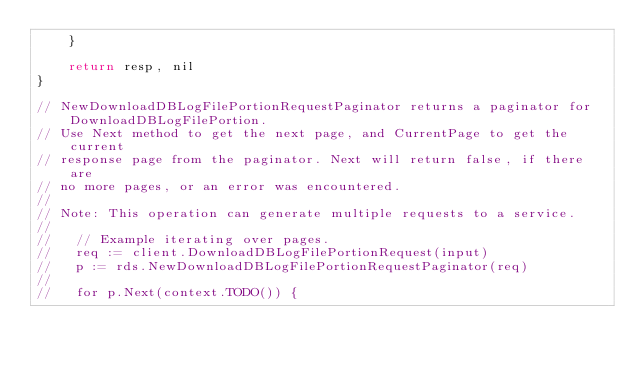Convert code to text. <code><loc_0><loc_0><loc_500><loc_500><_Go_>	}

	return resp, nil
}

// NewDownloadDBLogFilePortionRequestPaginator returns a paginator for DownloadDBLogFilePortion.
// Use Next method to get the next page, and CurrentPage to get the current
// response page from the paginator. Next will return false, if there are
// no more pages, or an error was encountered.
//
// Note: This operation can generate multiple requests to a service.
//
//   // Example iterating over pages.
//   req := client.DownloadDBLogFilePortionRequest(input)
//   p := rds.NewDownloadDBLogFilePortionRequestPaginator(req)
//
//   for p.Next(context.TODO()) {</code> 